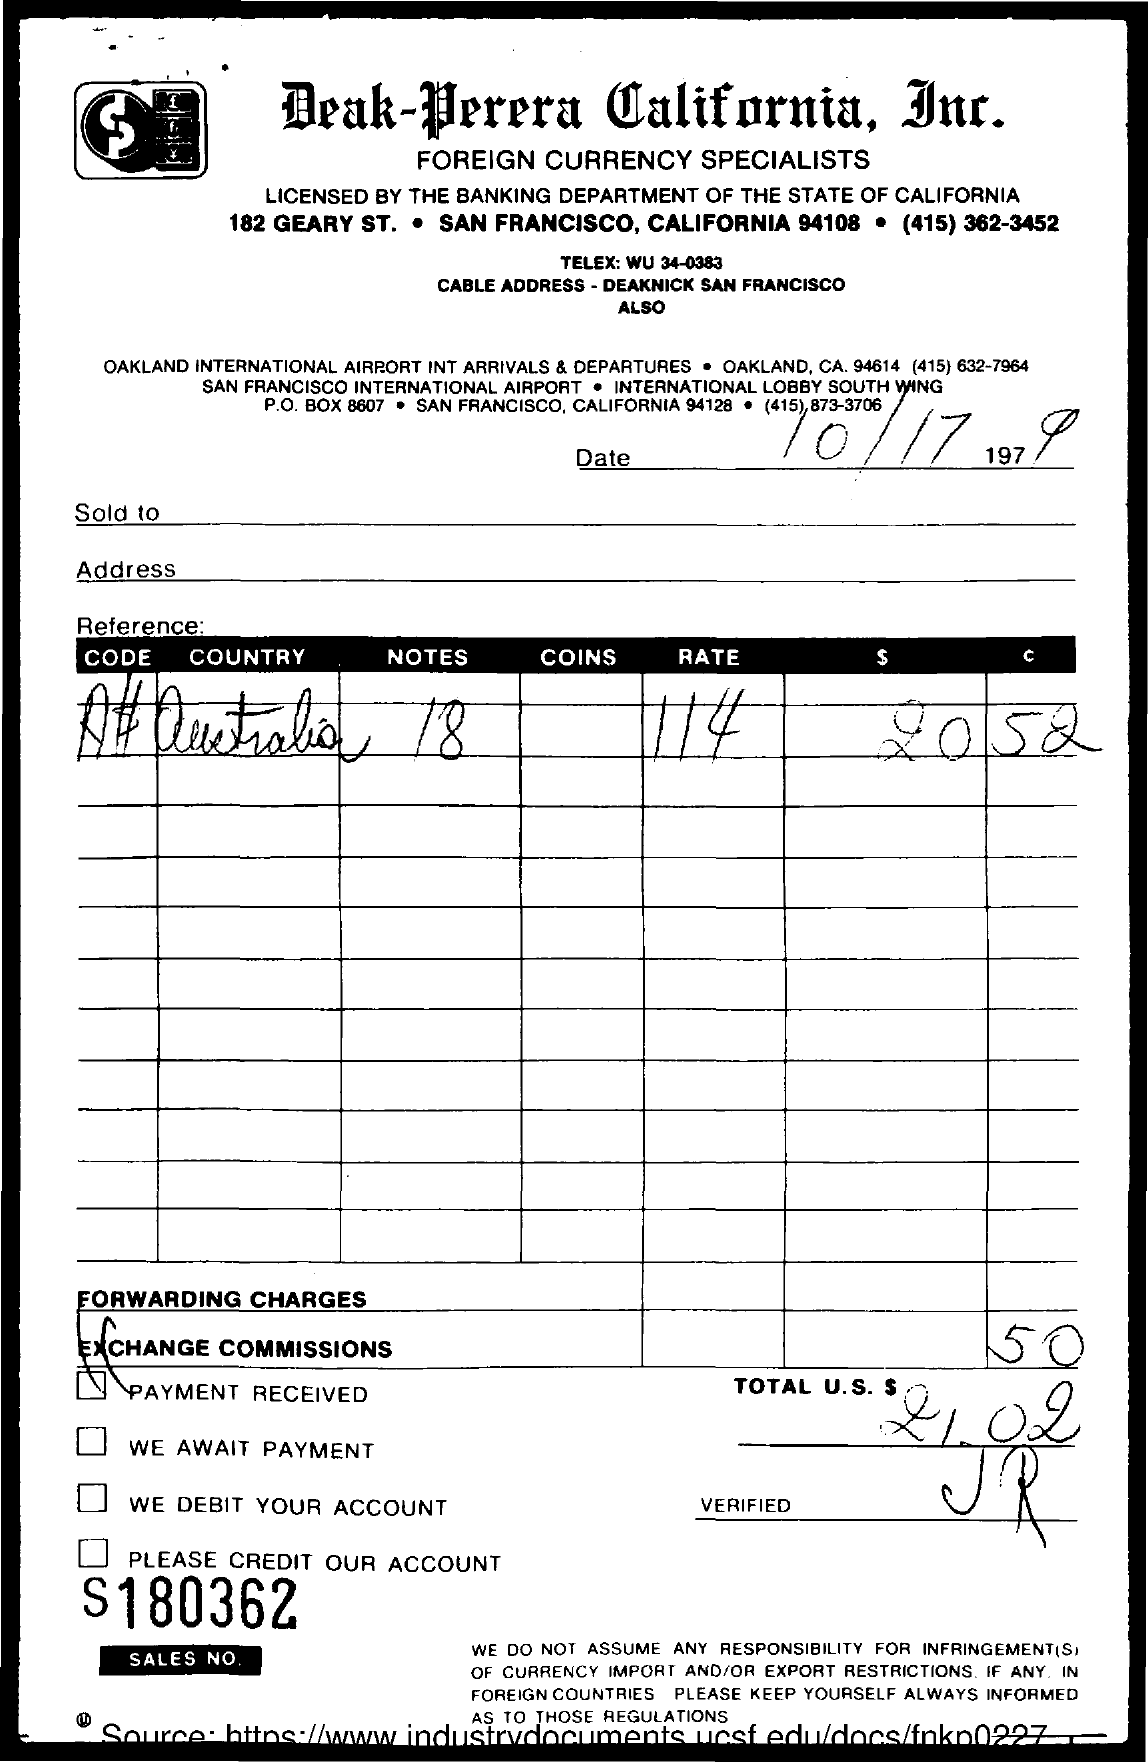What is the date mentioned?
Give a very brief answer. 10/17/1979. What is the country name of the currency?
Your answer should be very brief. Australia. What is the total number of notes?
Offer a very short reply. 18. What is the rate?
Ensure brevity in your answer.  114. What is the total U.S $?
Offer a very short reply. 21.02. 